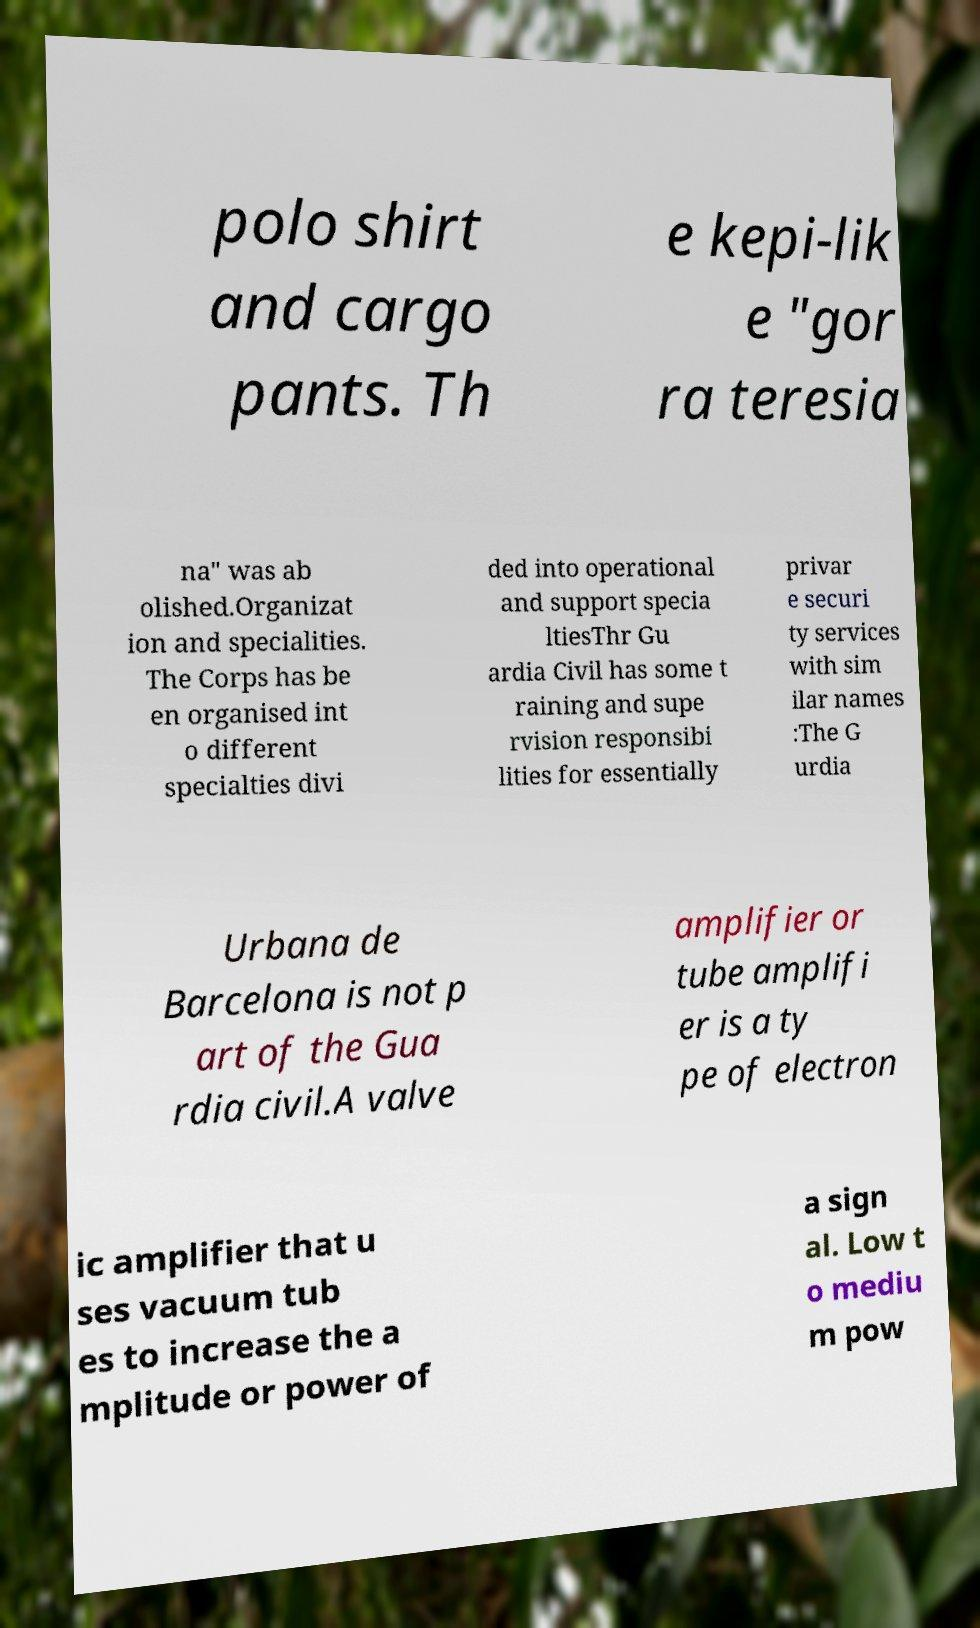What messages or text are displayed in this image? I need them in a readable, typed format. polo shirt and cargo pants. Th e kepi-lik e "gor ra teresia na" was ab olished.Organizat ion and specialities. The Corps has be en organised int o different specialties divi ded into operational and support specia ltiesThr Gu ardia Civil has some t raining and supe rvision responsibi lities for essentially privar e securi ty services with sim ilar names :The G urdia Urbana de Barcelona is not p art of the Gua rdia civil.A valve amplifier or tube amplifi er is a ty pe of electron ic amplifier that u ses vacuum tub es to increase the a mplitude or power of a sign al. Low t o mediu m pow 